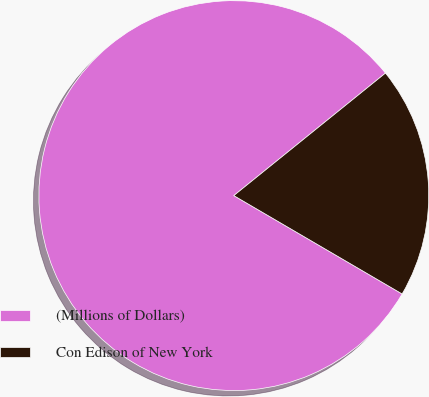Convert chart. <chart><loc_0><loc_0><loc_500><loc_500><pie_chart><fcel>(Millions of Dollars)<fcel>Con Edison of New York<nl><fcel>80.77%<fcel>19.23%<nl></chart> 